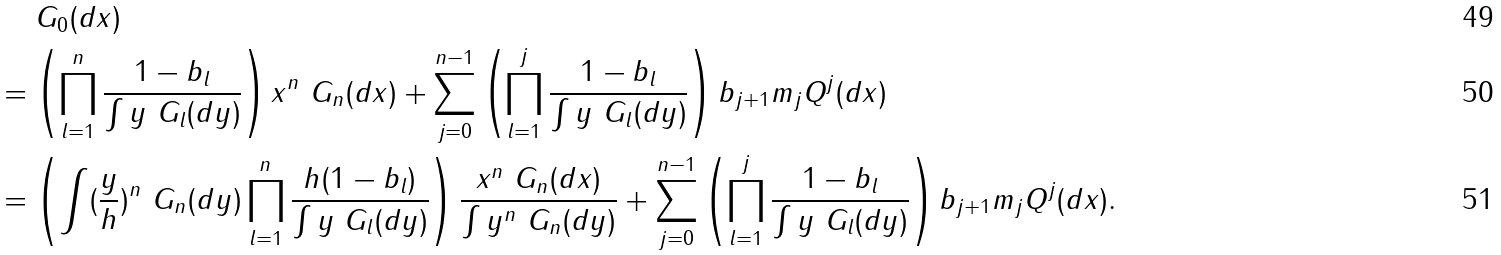<formula> <loc_0><loc_0><loc_500><loc_500>& \quad \ G _ { 0 } ( d x ) & \\ & = \left ( \prod _ { l = 1 } ^ { n } \frac { 1 - b _ { l } } { \int y \ G _ { l } ( d y ) } \right ) x ^ { n } \ G _ { n } ( d x ) + \sum _ { j = 0 } ^ { n - 1 } \left ( \prod _ { l = 1 } ^ { j } \frac { 1 - b _ { l } } { \int y \ G _ { l } ( d y ) } \right ) b _ { j + 1 } m _ { j } Q ^ { j } ( d x ) & \\ & = \left ( \int ( \frac { y } { h } ) ^ { n } \ G _ { n } ( d y ) \prod _ { l = 1 } ^ { n } \frac { h ( 1 - b _ { l } ) } { \int y \ G _ { l } ( d y ) } \right ) \frac { x ^ { n } \ G _ { n } ( d x ) } { \int y ^ { n } \ G _ { n } ( d y ) } + \sum _ { j = 0 } ^ { n - 1 } \left ( \prod _ { l = 1 } ^ { j } \frac { 1 - b _ { l } } { \int y \ G _ { l } ( d y ) } \right ) b _ { j + 1 } m _ { j } Q ^ { j } ( d x ) . &</formula> 